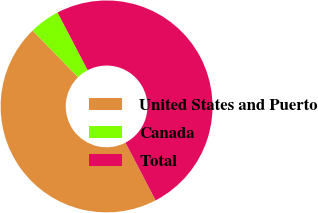<chart> <loc_0><loc_0><loc_500><loc_500><pie_chart><fcel>United States and Puerto<fcel>Canada<fcel>Total<nl><fcel>45.36%<fcel>4.64%<fcel>50.0%<nl></chart> 